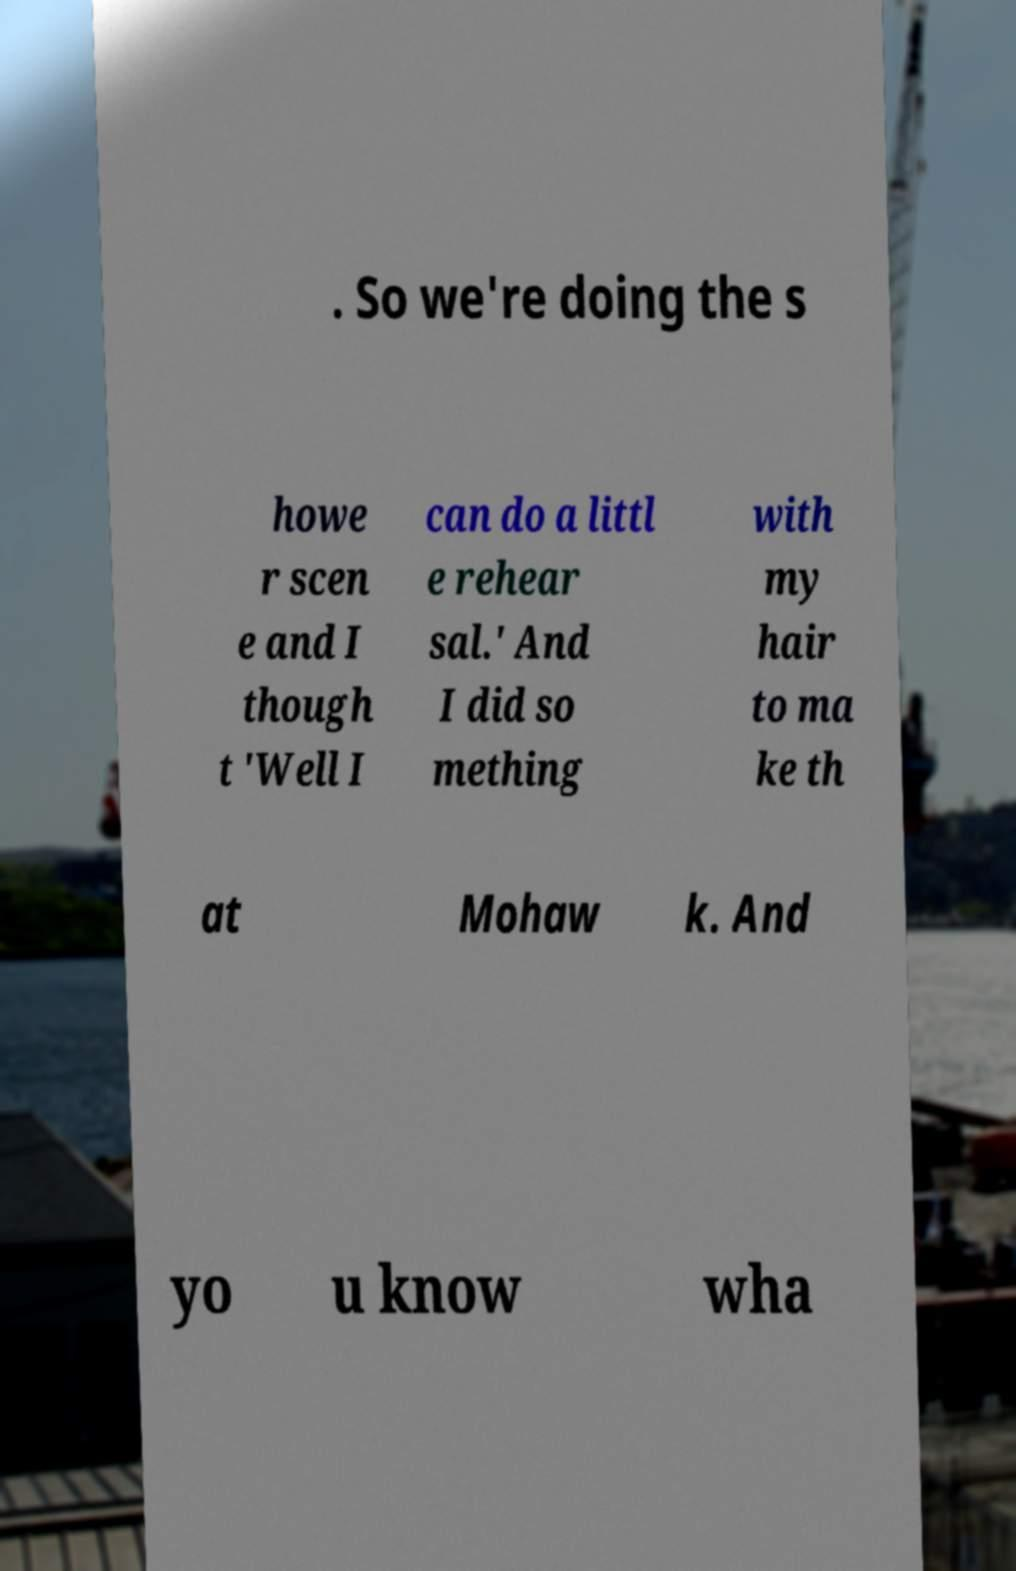Can you read and provide the text displayed in the image?This photo seems to have some interesting text. Can you extract and type it out for me? . So we're doing the s howe r scen e and I though t 'Well I can do a littl e rehear sal.' And I did so mething with my hair to ma ke th at Mohaw k. And yo u know wha 